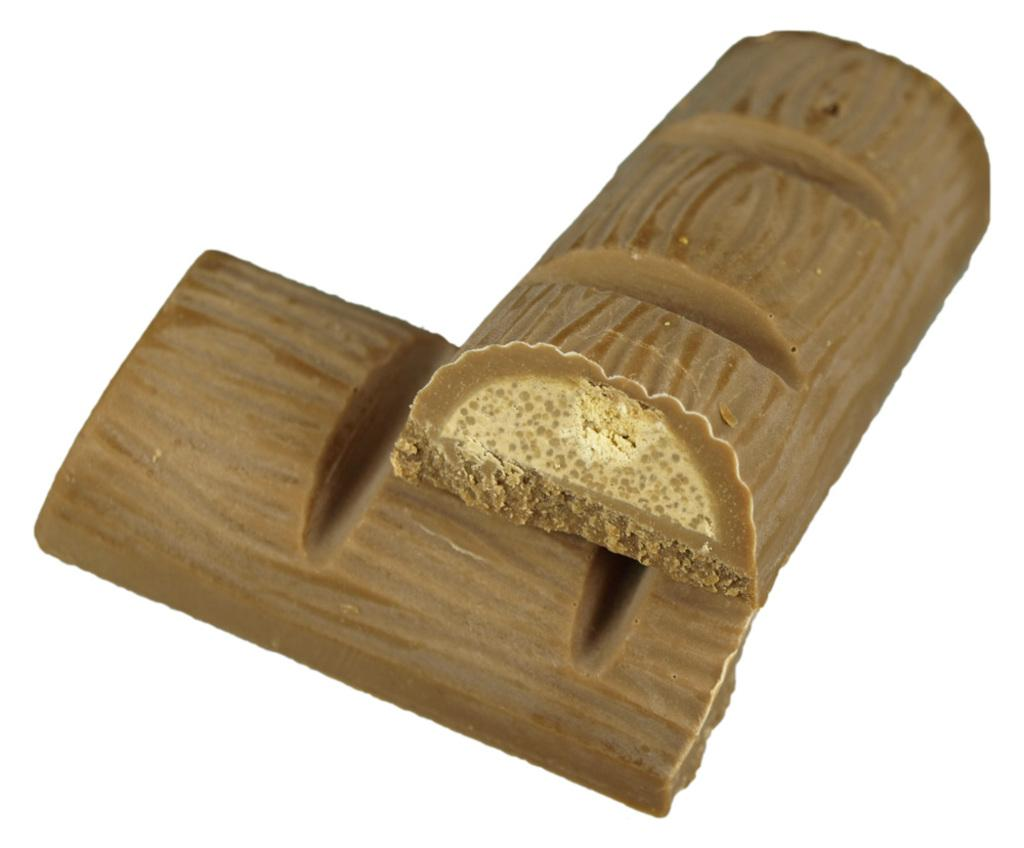What type of food is visible in the image? There are chocolate bars in the image. Where are the chocolate bars located? The chocolate bars are placed on a surface. What game is being played with the chocolate bars in the image? There is no game being played with the chocolate bars in the image; they are simply placed on a surface. How long will it take for the chocolate bars to burn in the image? The chocolate bars do not burn in the image; they are not exposed to any heat or flame. 